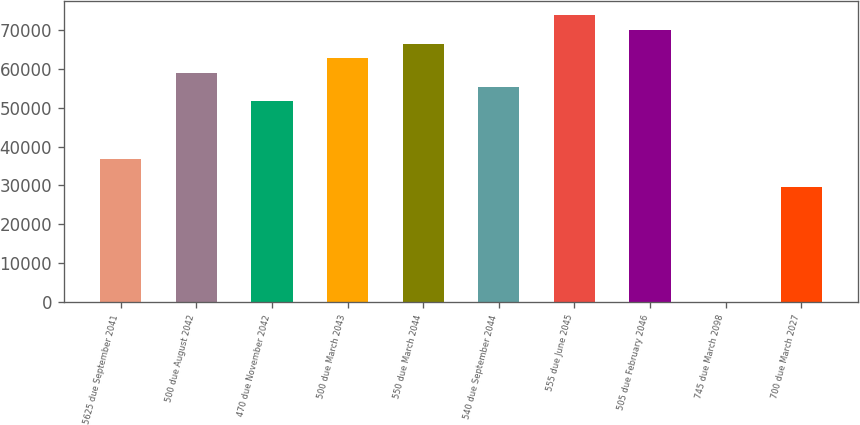Convert chart. <chart><loc_0><loc_0><loc_500><loc_500><bar_chart><fcel>5625 due September 2041<fcel>500 due August 2042<fcel>470 due November 2042<fcel>500 due March 2043<fcel>550 due March 2044<fcel>540 due September 2044<fcel>555 due June 2045<fcel>505 due February 2046<fcel>745 due March 2098<fcel>700 due March 2027<nl><fcel>36916<fcel>59050<fcel>51672<fcel>62739<fcel>66428<fcel>55361<fcel>73806<fcel>70117<fcel>26<fcel>29538<nl></chart> 